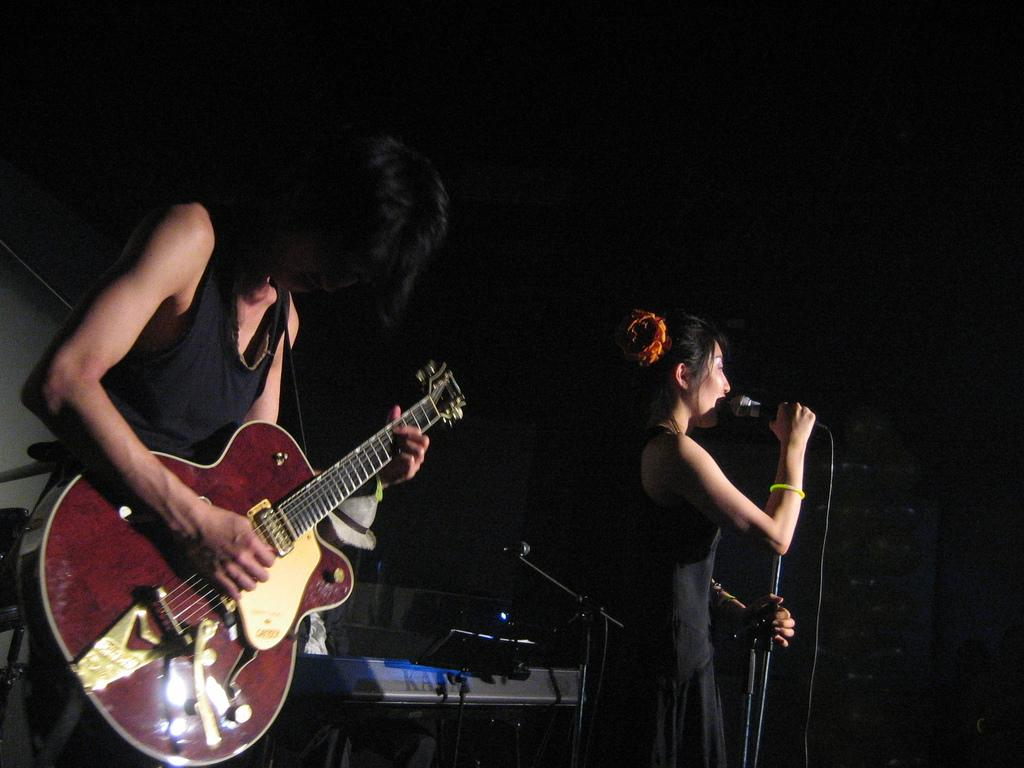How many people are in the image? There are two people in the image. What are the two people doing? One person is playing the guitar, and the other person is singing with a microphone. How is the person singing holding the microphone? The person singing is holding the microphone with one hand. What other musical instrument can be seen in the background of the image? There is a keyboard in the background of the image. How many passengers are visible in the image? There are no passengers present in the image; it features two people engaged in musical activities. What is the mass of the wristband worn by the person playing the guitar? There is no wristband visible on the person playing the guitar in the image. 